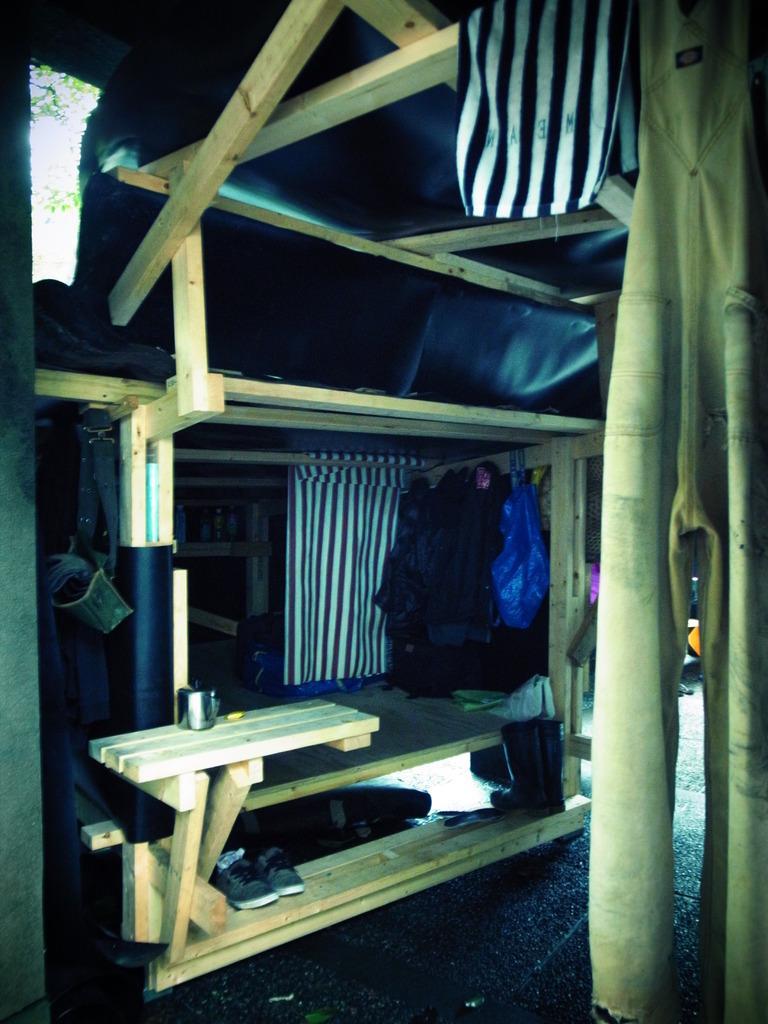Can you describe this image briefly? In this image, we can see wooden objects, clothes, cover, boots, shoes, few things. At the bottom, we can see surface. On the left side of the image, we can see tree leaves. 